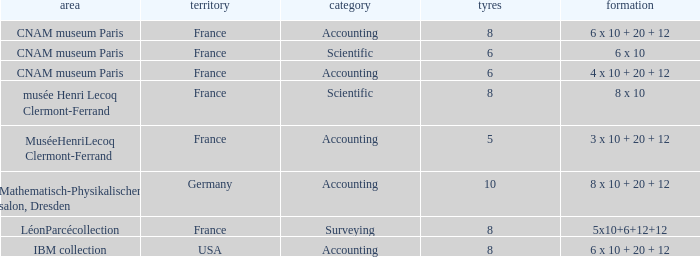What is the configuration for the country France, with accounting as the type, and wheels greater than 6? 6 x 10 + 20 + 12. 